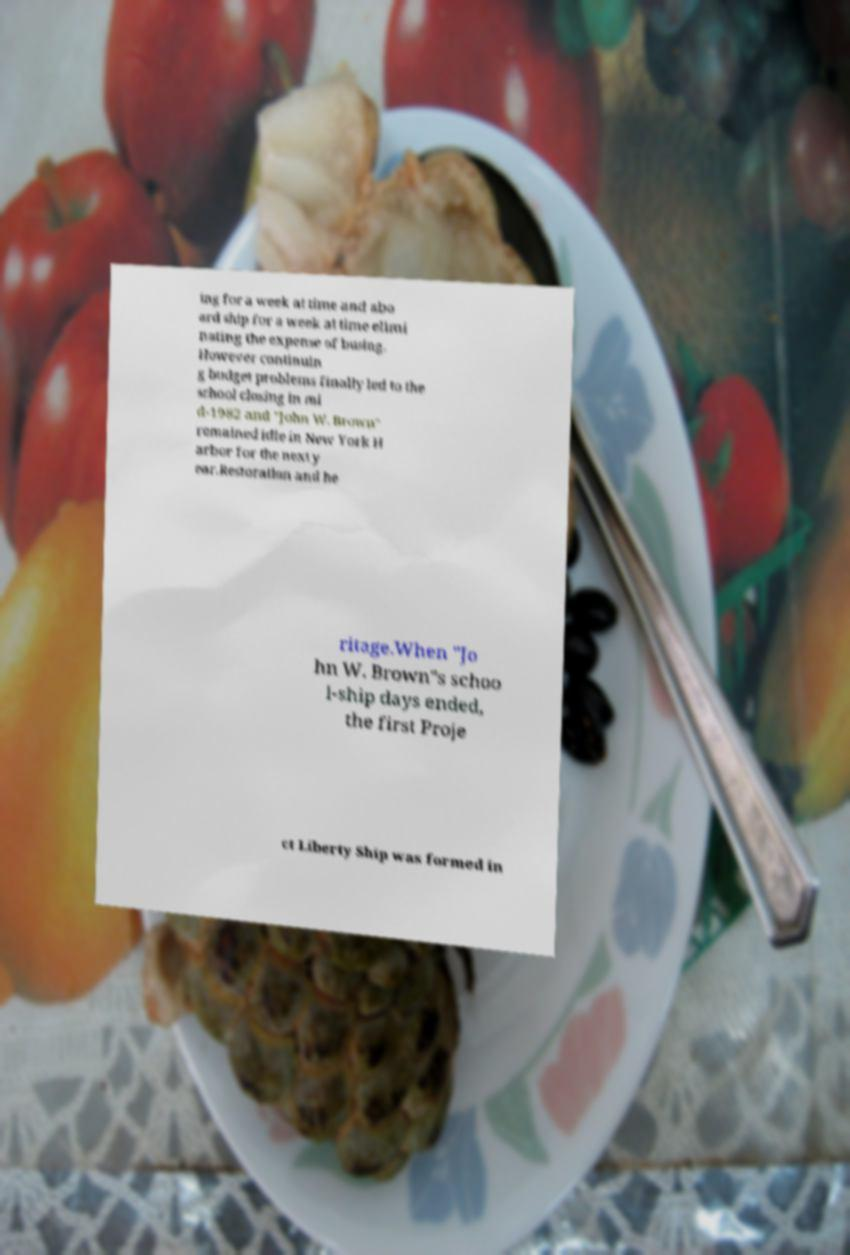Please read and relay the text visible in this image. What does it say? ing for a week at time and abo ard ship for a week at time elimi nating the expense of busing. However continuin g budget problems finally led to the school closing in mi d-1982 and "John W. Brown" remained idle in New York H arbor for the next y ear.Restoration and he ritage.When "Jo hn W. Brown"s schoo l-ship days ended, the first Proje ct Liberty Ship was formed in 